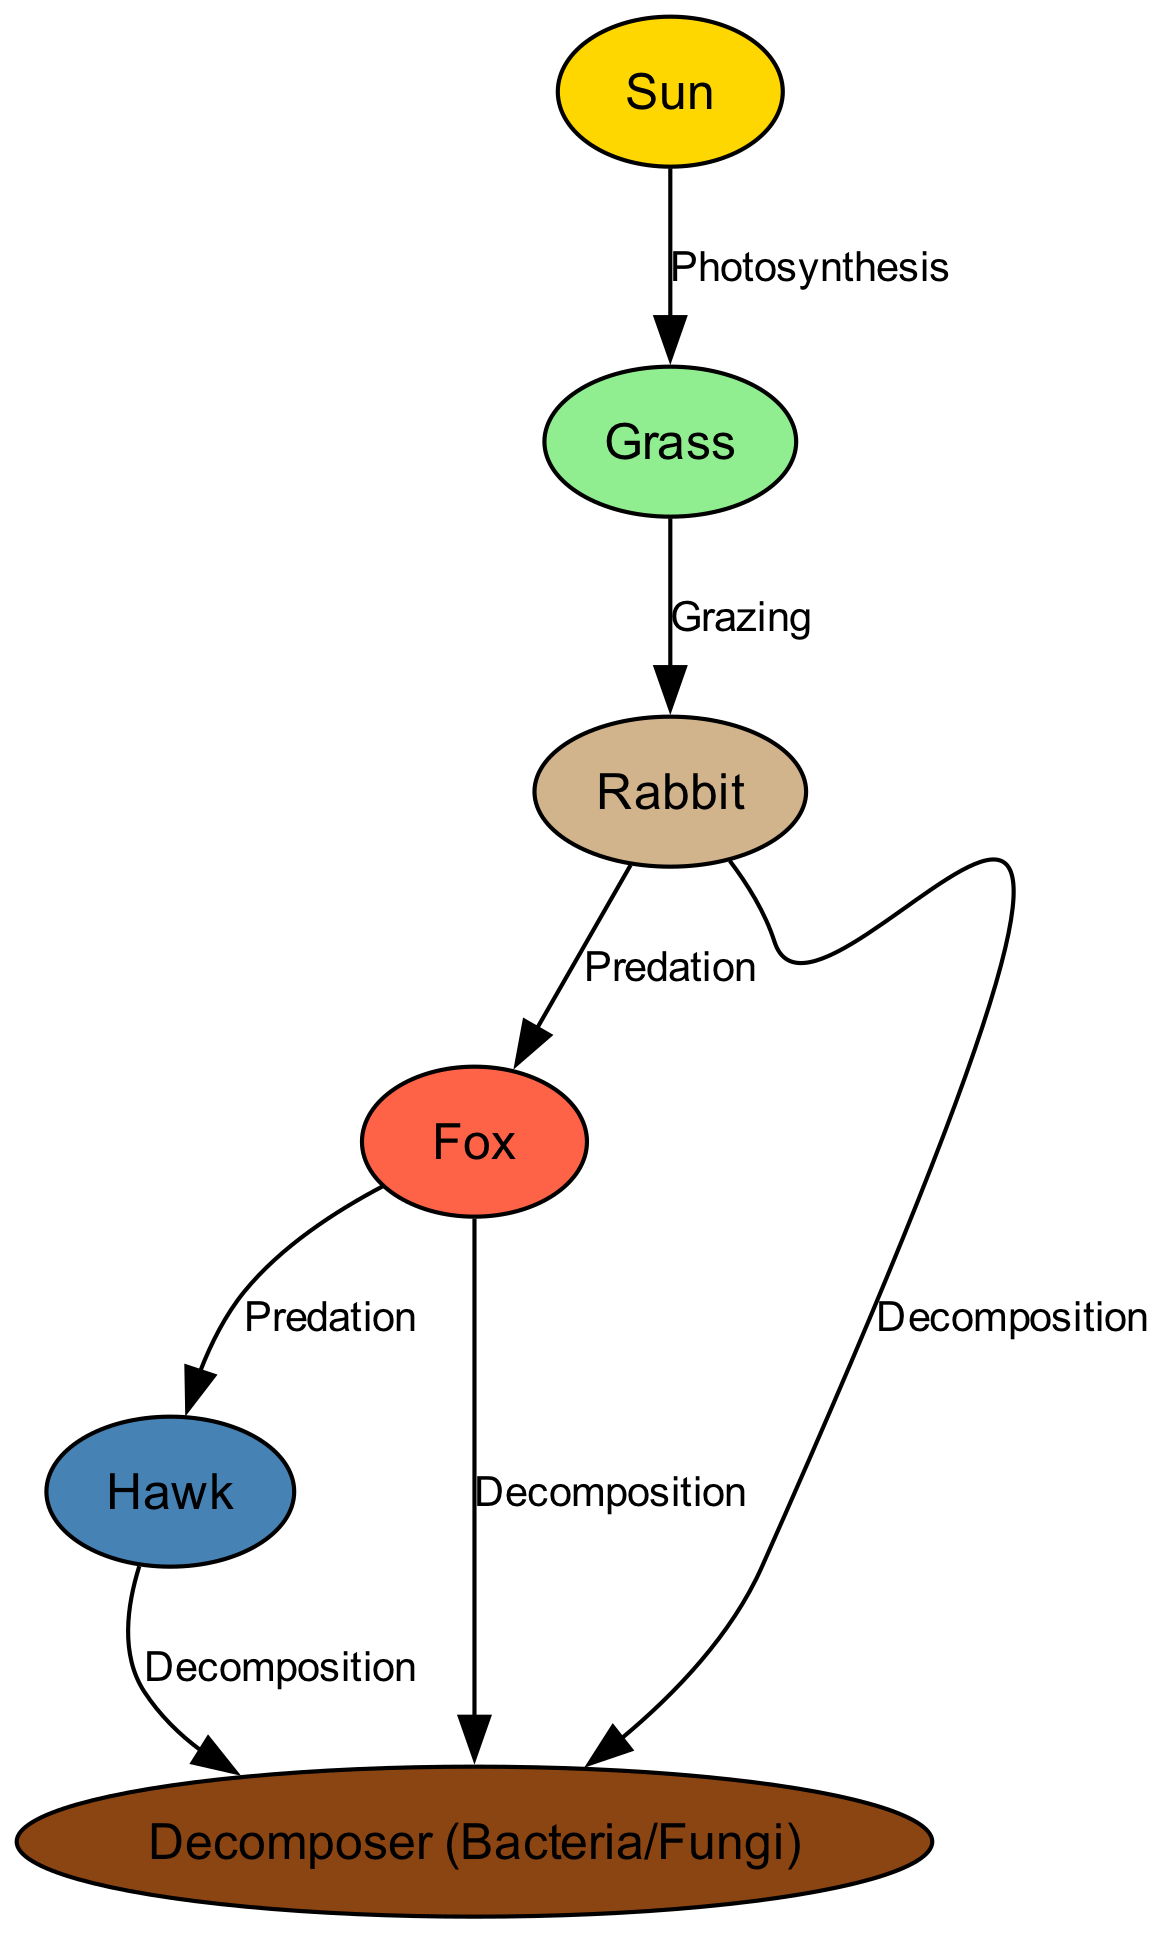What is the first node in the food chain? The first node represents the primary source of energy in the food chain, which is the Sun. In the diagram, it is labeled as "Sun."
Answer: Sun How many nodes are there in the diagram? By counting the colored circles, we identify six distinct organisms or categories, giving us a total of six nodes: Sun, Grass, Rabbit, Fox, Hawk, and Decomposer.
Answer: 6 What role does grass play in the food chain? Grass is depicted as a primary producer in the food chain. It receives energy from the Sun through photosynthesis, which allows it to grow and serve as food for herbivores like the Rabbit.
Answer: Primary producer Who are the primary consumers in the food chain? The primary consumers are the organisms that directly feed on the primary producers. In this case, the Rabbit is the primary consumer that grazes on Grass.
Answer: Rabbit What process connects the sun to the grass? The connection between the sun and grass is established through photosynthesis, where the plants convert sunlight into energy, allowing for their growth.
Answer: Photosynthesis How many predation relationships are in the diagram? By examining the edges, we find two instances of predation: Rabbit → Fox and Fox → Hawk, indicating there are two direct predation relationships in the food chain.
Answer: 2 What happens to the rabbit after it is consumed by the fox? After the rabbit is eaten by the fox, its body contributes to the ecosystem through decomposition, where the organic matter is broken down by decomposers like bacteria and fungi.
Answer: Decomposition Which node has the most outgoing edges connecting to decomposers? The nodes Rabbit, Fox, and Hawk each connect to the Decomposer through decomposition, showing they all contribute to this process in the food chain.
Answer: Rabbit, Fox, Hawk What connects the fox to the hawk? The link between the fox and the hawk is established through a predation relationship, where the hawk preys on the fox, completing the food chain dynamics.
Answer: Predation 